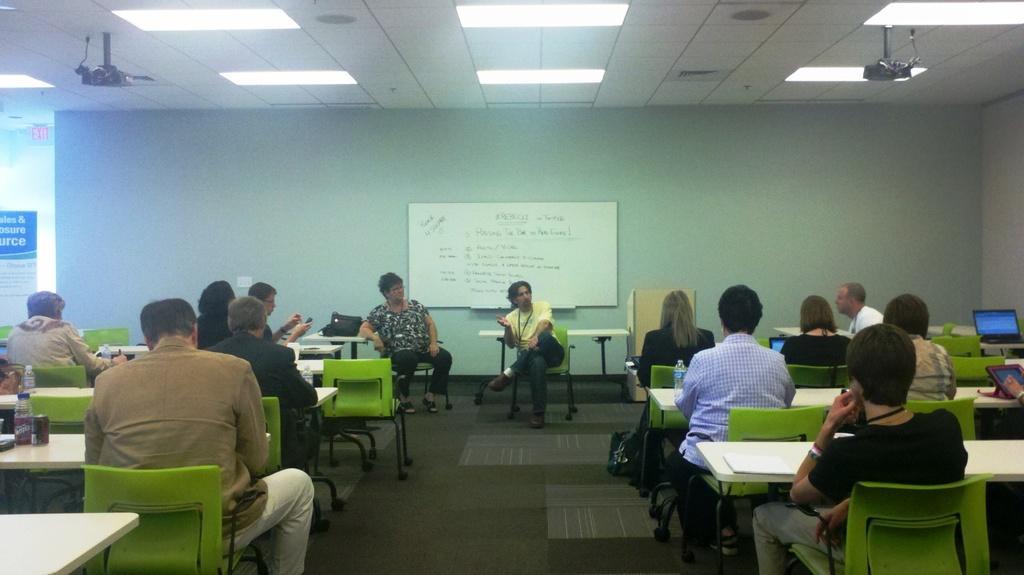Please provide a concise description of this image. It is a classroom there are lot of chairs and tables,some people are sitting in front of the tables,in the first row to right side there are some monitors on the table,in the front a woman and men are sitting,there are speaking something,in the background there is white board to the wall,to the roof there are two projectors on the other side and also some lights. 